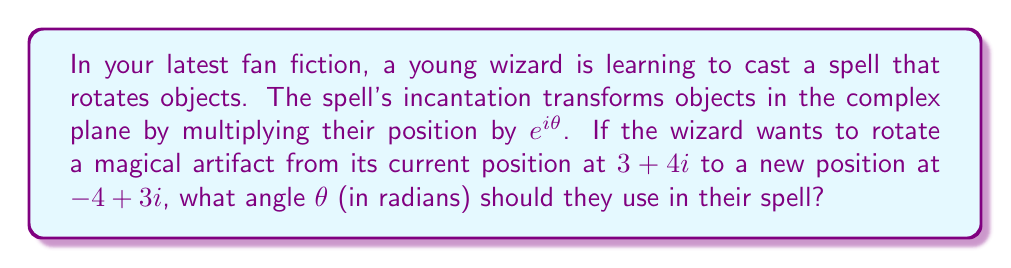What is the answer to this math problem? Let's approach this step-by-step:

1) The initial position of the artifact is $z_1 = 3+4i$.

2) The final position after rotation is $z_2 = -4+3i$.

3) The rotation is described by the equation:
   $z_2 = z_1 \cdot e^{i\theta}$

4) To find $\theta$, we can divide both sides by $z_1$:
   $\frac{z_2}{z_1} = e^{i\theta}$

5) Let's calculate $\frac{z_2}{z_1}$:
   $$\frac{z_2}{z_1} = \frac{-4+3i}{3+4i} \cdot \frac{3-4i}{3-4i} = \frac{(-4+3i)(3-4i)}{(3+4i)(3-4i)} = \frac{-12-16i+9i-12i^2}{9+16} = \frac{0-19i}{25} = -\frac{19}{25}i$$

6) So, $e^{i\theta} = -\frac{19}{25}i$

7) To find $\theta$, we can use the complex logarithm:
   $\theta = \arg(-\frac{19}{25}i) = \arg(i) - \arg(\frac{25}{19}) = \frac{\pi}{2} - \arctan(\frac{25}{19})$

8) Calculate the final result:
   $\theta = \frac{\pi}{2} - \arctan(\frac{25}{19}) \approx 1.5708 - 0.9185 \approx 0.6523$ radians
Answer: $\theta = \frac{\pi}{2} - \arctan(\frac{25}{19}) \approx 0.6523$ radians 